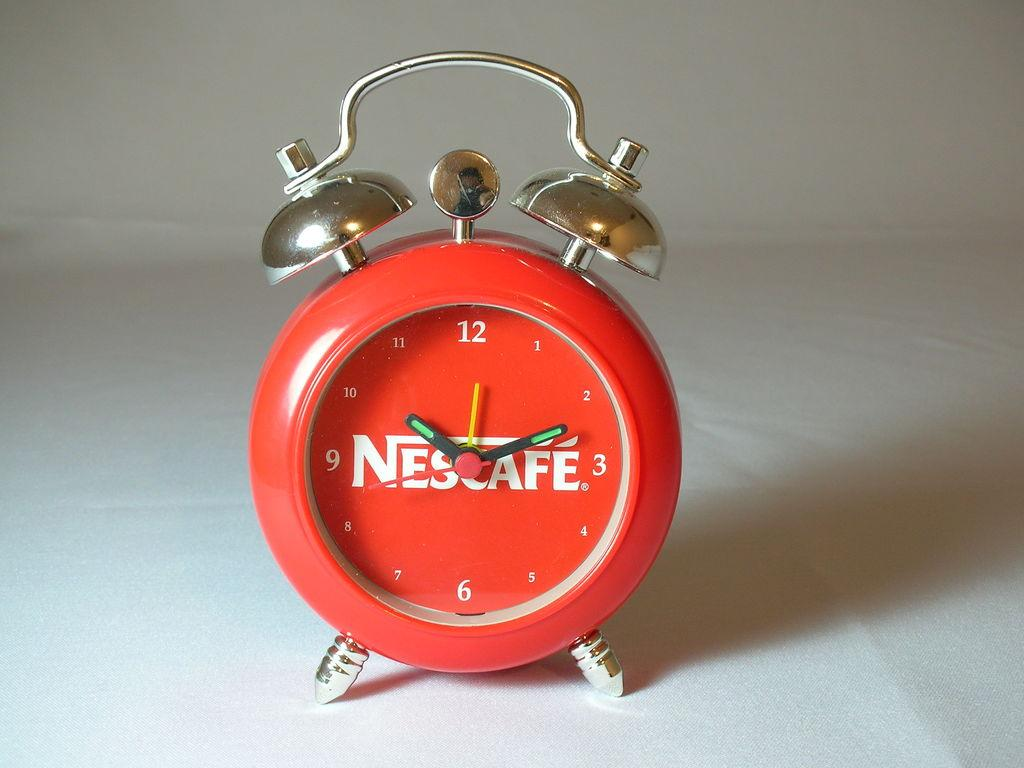<image>
Describe the image concisely. A red old fashioned alarm clock has the word Nescafe printed in the center of its face. 